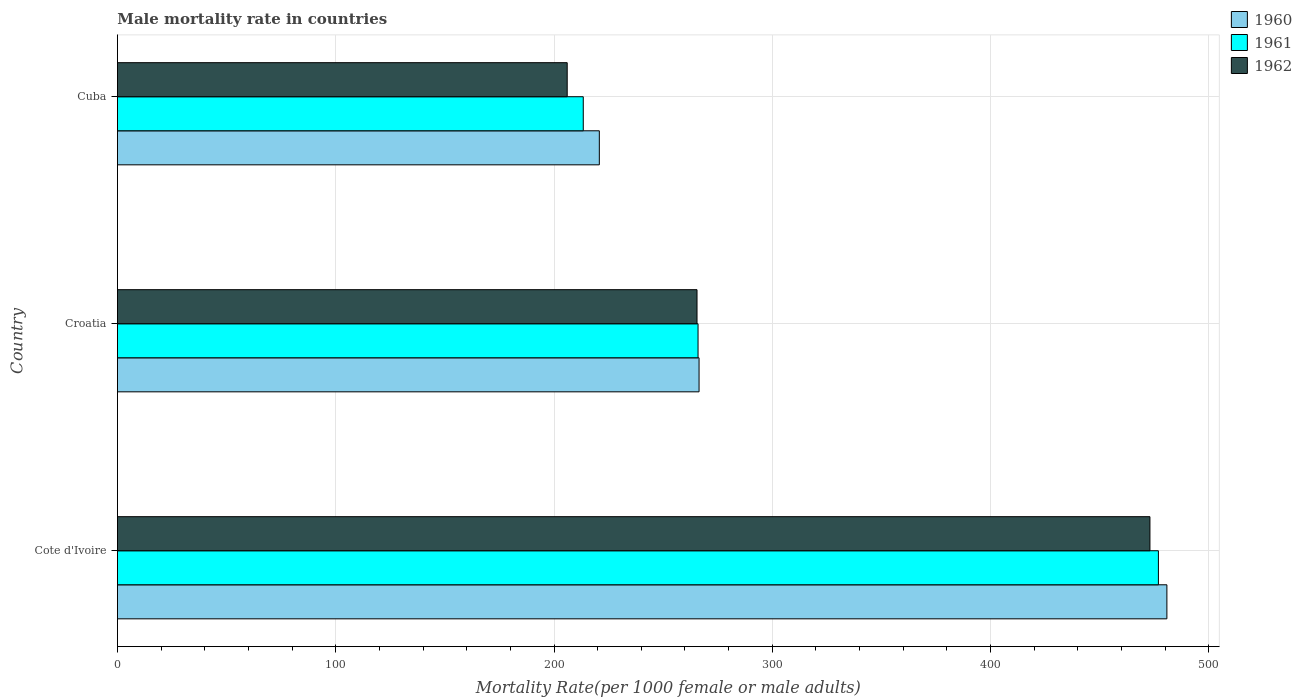Are the number of bars per tick equal to the number of legend labels?
Your answer should be compact. Yes. Are the number of bars on each tick of the Y-axis equal?
Provide a succinct answer. Yes. What is the label of the 1st group of bars from the top?
Provide a succinct answer. Cuba. In how many cases, is the number of bars for a given country not equal to the number of legend labels?
Ensure brevity in your answer.  0. What is the male mortality rate in 1960 in Croatia?
Give a very brief answer. 266.45. Across all countries, what is the maximum male mortality rate in 1962?
Ensure brevity in your answer.  473. Across all countries, what is the minimum male mortality rate in 1962?
Provide a succinct answer. 206.05. In which country was the male mortality rate in 1962 maximum?
Provide a succinct answer. Cote d'Ivoire. In which country was the male mortality rate in 1960 minimum?
Your answer should be compact. Cuba. What is the total male mortality rate in 1961 in the graph?
Give a very brief answer. 956.27. What is the difference between the male mortality rate in 1962 in Cote d'Ivoire and that in Croatia?
Your answer should be compact. 207.48. What is the difference between the male mortality rate in 1961 in Croatia and the male mortality rate in 1960 in Cuba?
Give a very brief answer. 45.22. What is the average male mortality rate in 1962 per country?
Your answer should be very brief. 314.85. What is the difference between the male mortality rate in 1960 and male mortality rate in 1961 in Cuba?
Give a very brief answer. 7.36. What is the ratio of the male mortality rate in 1961 in Croatia to that in Cuba?
Provide a succinct answer. 1.25. Is the male mortality rate in 1962 in Cote d'Ivoire less than that in Cuba?
Offer a very short reply. No. What is the difference between the highest and the second highest male mortality rate in 1960?
Your answer should be compact. 214.31. What is the difference between the highest and the lowest male mortality rate in 1960?
Provide a succinct answer. 260. In how many countries, is the male mortality rate in 1961 greater than the average male mortality rate in 1961 taken over all countries?
Provide a succinct answer. 1. Is the sum of the male mortality rate in 1961 in Cote d'Ivoire and Croatia greater than the maximum male mortality rate in 1960 across all countries?
Ensure brevity in your answer.  Yes. What does the 1st bar from the bottom in Cuba represents?
Ensure brevity in your answer.  1960. Is it the case that in every country, the sum of the male mortality rate in 1962 and male mortality rate in 1961 is greater than the male mortality rate in 1960?
Ensure brevity in your answer.  Yes. Are all the bars in the graph horizontal?
Offer a terse response. Yes. Are the values on the major ticks of X-axis written in scientific E-notation?
Your answer should be compact. No. Does the graph contain any zero values?
Keep it short and to the point. No. How many legend labels are there?
Offer a terse response. 3. What is the title of the graph?
Make the answer very short. Male mortality rate in countries. Does "2005" appear as one of the legend labels in the graph?
Keep it short and to the point. No. What is the label or title of the X-axis?
Offer a terse response. Mortality Rate(per 1000 female or male adults). What is the Mortality Rate(per 1000 female or male adults) in 1960 in Cote d'Ivoire?
Your answer should be very brief. 480.76. What is the Mortality Rate(per 1000 female or male adults) in 1961 in Cote d'Ivoire?
Provide a short and direct response. 476.88. What is the Mortality Rate(per 1000 female or male adults) in 1962 in Cote d'Ivoire?
Ensure brevity in your answer.  473. What is the Mortality Rate(per 1000 female or male adults) of 1960 in Croatia?
Provide a succinct answer. 266.45. What is the Mortality Rate(per 1000 female or male adults) of 1961 in Croatia?
Your answer should be very brief. 265.99. What is the Mortality Rate(per 1000 female or male adults) of 1962 in Croatia?
Ensure brevity in your answer.  265.52. What is the Mortality Rate(per 1000 female or male adults) in 1960 in Cuba?
Offer a very short reply. 220.76. What is the Mortality Rate(per 1000 female or male adults) in 1961 in Cuba?
Give a very brief answer. 213.41. What is the Mortality Rate(per 1000 female or male adults) in 1962 in Cuba?
Ensure brevity in your answer.  206.05. Across all countries, what is the maximum Mortality Rate(per 1000 female or male adults) in 1960?
Give a very brief answer. 480.76. Across all countries, what is the maximum Mortality Rate(per 1000 female or male adults) in 1961?
Make the answer very short. 476.88. Across all countries, what is the maximum Mortality Rate(per 1000 female or male adults) of 1962?
Your answer should be very brief. 473. Across all countries, what is the minimum Mortality Rate(per 1000 female or male adults) in 1960?
Give a very brief answer. 220.76. Across all countries, what is the minimum Mortality Rate(per 1000 female or male adults) in 1961?
Offer a terse response. 213.41. Across all countries, what is the minimum Mortality Rate(per 1000 female or male adults) of 1962?
Keep it short and to the point. 206.05. What is the total Mortality Rate(per 1000 female or male adults) in 1960 in the graph?
Keep it short and to the point. 967.98. What is the total Mortality Rate(per 1000 female or male adults) in 1961 in the graph?
Your response must be concise. 956.27. What is the total Mortality Rate(per 1000 female or male adults) of 1962 in the graph?
Provide a succinct answer. 944.56. What is the difference between the Mortality Rate(per 1000 female or male adults) in 1960 in Cote d'Ivoire and that in Croatia?
Your answer should be compact. 214.31. What is the difference between the Mortality Rate(per 1000 female or male adults) of 1961 in Cote d'Ivoire and that in Croatia?
Your response must be concise. 210.89. What is the difference between the Mortality Rate(per 1000 female or male adults) in 1962 in Cote d'Ivoire and that in Croatia?
Your response must be concise. 207.48. What is the difference between the Mortality Rate(per 1000 female or male adults) in 1960 in Cote d'Ivoire and that in Cuba?
Keep it short and to the point. 260. What is the difference between the Mortality Rate(per 1000 female or male adults) in 1961 in Cote d'Ivoire and that in Cuba?
Make the answer very short. 263.47. What is the difference between the Mortality Rate(per 1000 female or male adults) in 1962 in Cote d'Ivoire and that in Cuba?
Give a very brief answer. 266.95. What is the difference between the Mortality Rate(per 1000 female or male adults) of 1960 in Croatia and that in Cuba?
Offer a terse response. 45.69. What is the difference between the Mortality Rate(per 1000 female or male adults) of 1961 in Croatia and that in Cuba?
Your response must be concise. 52.58. What is the difference between the Mortality Rate(per 1000 female or male adults) in 1962 in Croatia and that in Cuba?
Keep it short and to the point. 59.47. What is the difference between the Mortality Rate(per 1000 female or male adults) of 1960 in Cote d'Ivoire and the Mortality Rate(per 1000 female or male adults) of 1961 in Croatia?
Make the answer very short. 214.78. What is the difference between the Mortality Rate(per 1000 female or male adults) of 1960 in Cote d'Ivoire and the Mortality Rate(per 1000 female or male adults) of 1962 in Croatia?
Keep it short and to the point. 215.25. What is the difference between the Mortality Rate(per 1000 female or male adults) of 1961 in Cote d'Ivoire and the Mortality Rate(per 1000 female or male adults) of 1962 in Croatia?
Provide a succinct answer. 211.36. What is the difference between the Mortality Rate(per 1000 female or male adults) in 1960 in Cote d'Ivoire and the Mortality Rate(per 1000 female or male adults) in 1961 in Cuba?
Provide a succinct answer. 267.36. What is the difference between the Mortality Rate(per 1000 female or male adults) of 1960 in Cote d'Ivoire and the Mortality Rate(per 1000 female or male adults) of 1962 in Cuba?
Your answer should be compact. 274.72. What is the difference between the Mortality Rate(per 1000 female or male adults) of 1961 in Cote d'Ivoire and the Mortality Rate(per 1000 female or male adults) of 1962 in Cuba?
Provide a short and direct response. 270.83. What is the difference between the Mortality Rate(per 1000 female or male adults) in 1960 in Croatia and the Mortality Rate(per 1000 female or male adults) in 1961 in Cuba?
Make the answer very short. 53.05. What is the difference between the Mortality Rate(per 1000 female or male adults) in 1960 in Croatia and the Mortality Rate(per 1000 female or male adults) in 1962 in Cuba?
Provide a succinct answer. 60.41. What is the difference between the Mortality Rate(per 1000 female or male adults) of 1961 in Croatia and the Mortality Rate(per 1000 female or male adults) of 1962 in Cuba?
Offer a very short reply. 59.94. What is the average Mortality Rate(per 1000 female or male adults) of 1960 per country?
Make the answer very short. 322.66. What is the average Mortality Rate(per 1000 female or male adults) of 1961 per country?
Give a very brief answer. 318.76. What is the average Mortality Rate(per 1000 female or male adults) in 1962 per country?
Provide a short and direct response. 314.85. What is the difference between the Mortality Rate(per 1000 female or male adults) of 1960 and Mortality Rate(per 1000 female or male adults) of 1961 in Cote d'Ivoire?
Ensure brevity in your answer.  3.88. What is the difference between the Mortality Rate(per 1000 female or male adults) of 1960 and Mortality Rate(per 1000 female or male adults) of 1962 in Cote d'Ivoire?
Provide a succinct answer. 7.77. What is the difference between the Mortality Rate(per 1000 female or male adults) in 1961 and Mortality Rate(per 1000 female or male adults) in 1962 in Cote d'Ivoire?
Ensure brevity in your answer.  3.88. What is the difference between the Mortality Rate(per 1000 female or male adults) of 1960 and Mortality Rate(per 1000 female or male adults) of 1961 in Croatia?
Ensure brevity in your answer.  0.47. What is the difference between the Mortality Rate(per 1000 female or male adults) of 1960 and Mortality Rate(per 1000 female or male adults) of 1962 in Croatia?
Keep it short and to the point. 0.94. What is the difference between the Mortality Rate(per 1000 female or male adults) in 1961 and Mortality Rate(per 1000 female or male adults) in 1962 in Croatia?
Offer a terse response. 0.47. What is the difference between the Mortality Rate(per 1000 female or male adults) in 1960 and Mortality Rate(per 1000 female or male adults) in 1961 in Cuba?
Provide a short and direct response. 7.36. What is the difference between the Mortality Rate(per 1000 female or male adults) in 1960 and Mortality Rate(per 1000 female or male adults) in 1962 in Cuba?
Provide a short and direct response. 14.72. What is the difference between the Mortality Rate(per 1000 female or male adults) in 1961 and Mortality Rate(per 1000 female or male adults) in 1962 in Cuba?
Your answer should be very brief. 7.36. What is the ratio of the Mortality Rate(per 1000 female or male adults) in 1960 in Cote d'Ivoire to that in Croatia?
Ensure brevity in your answer.  1.8. What is the ratio of the Mortality Rate(per 1000 female or male adults) of 1961 in Cote d'Ivoire to that in Croatia?
Make the answer very short. 1.79. What is the ratio of the Mortality Rate(per 1000 female or male adults) in 1962 in Cote d'Ivoire to that in Croatia?
Your answer should be very brief. 1.78. What is the ratio of the Mortality Rate(per 1000 female or male adults) of 1960 in Cote d'Ivoire to that in Cuba?
Ensure brevity in your answer.  2.18. What is the ratio of the Mortality Rate(per 1000 female or male adults) in 1961 in Cote d'Ivoire to that in Cuba?
Provide a succinct answer. 2.23. What is the ratio of the Mortality Rate(per 1000 female or male adults) of 1962 in Cote d'Ivoire to that in Cuba?
Offer a terse response. 2.3. What is the ratio of the Mortality Rate(per 1000 female or male adults) of 1960 in Croatia to that in Cuba?
Provide a short and direct response. 1.21. What is the ratio of the Mortality Rate(per 1000 female or male adults) in 1961 in Croatia to that in Cuba?
Give a very brief answer. 1.25. What is the ratio of the Mortality Rate(per 1000 female or male adults) in 1962 in Croatia to that in Cuba?
Offer a very short reply. 1.29. What is the difference between the highest and the second highest Mortality Rate(per 1000 female or male adults) of 1960?
Provide a succinct answer. 214.31. What is the difference between the highest and the second highest Mortality Rate(per 1000 female or male adults) in 1961?
Keep it short and to the point. 210.89. What is the difference between the highest and the second highest Mortality Rate(per 1000 female or male adults) in 1962?
Your answer should be compact. 207.48. What is the difference between the highest and the lowest Mortality Rate(per 1000 female or male adults) of 1960?
Make the answer very short. 260. What is the difference between the highest and the lowest Mortality Rate(per 1000 female or male adults) in 1961?
Your response must be concise. 263.47. What is the difference between the highest and the lowest Mortality Rate(per 1000 female or male adults) of 1962?
Your answer should be compact. 266.95. 